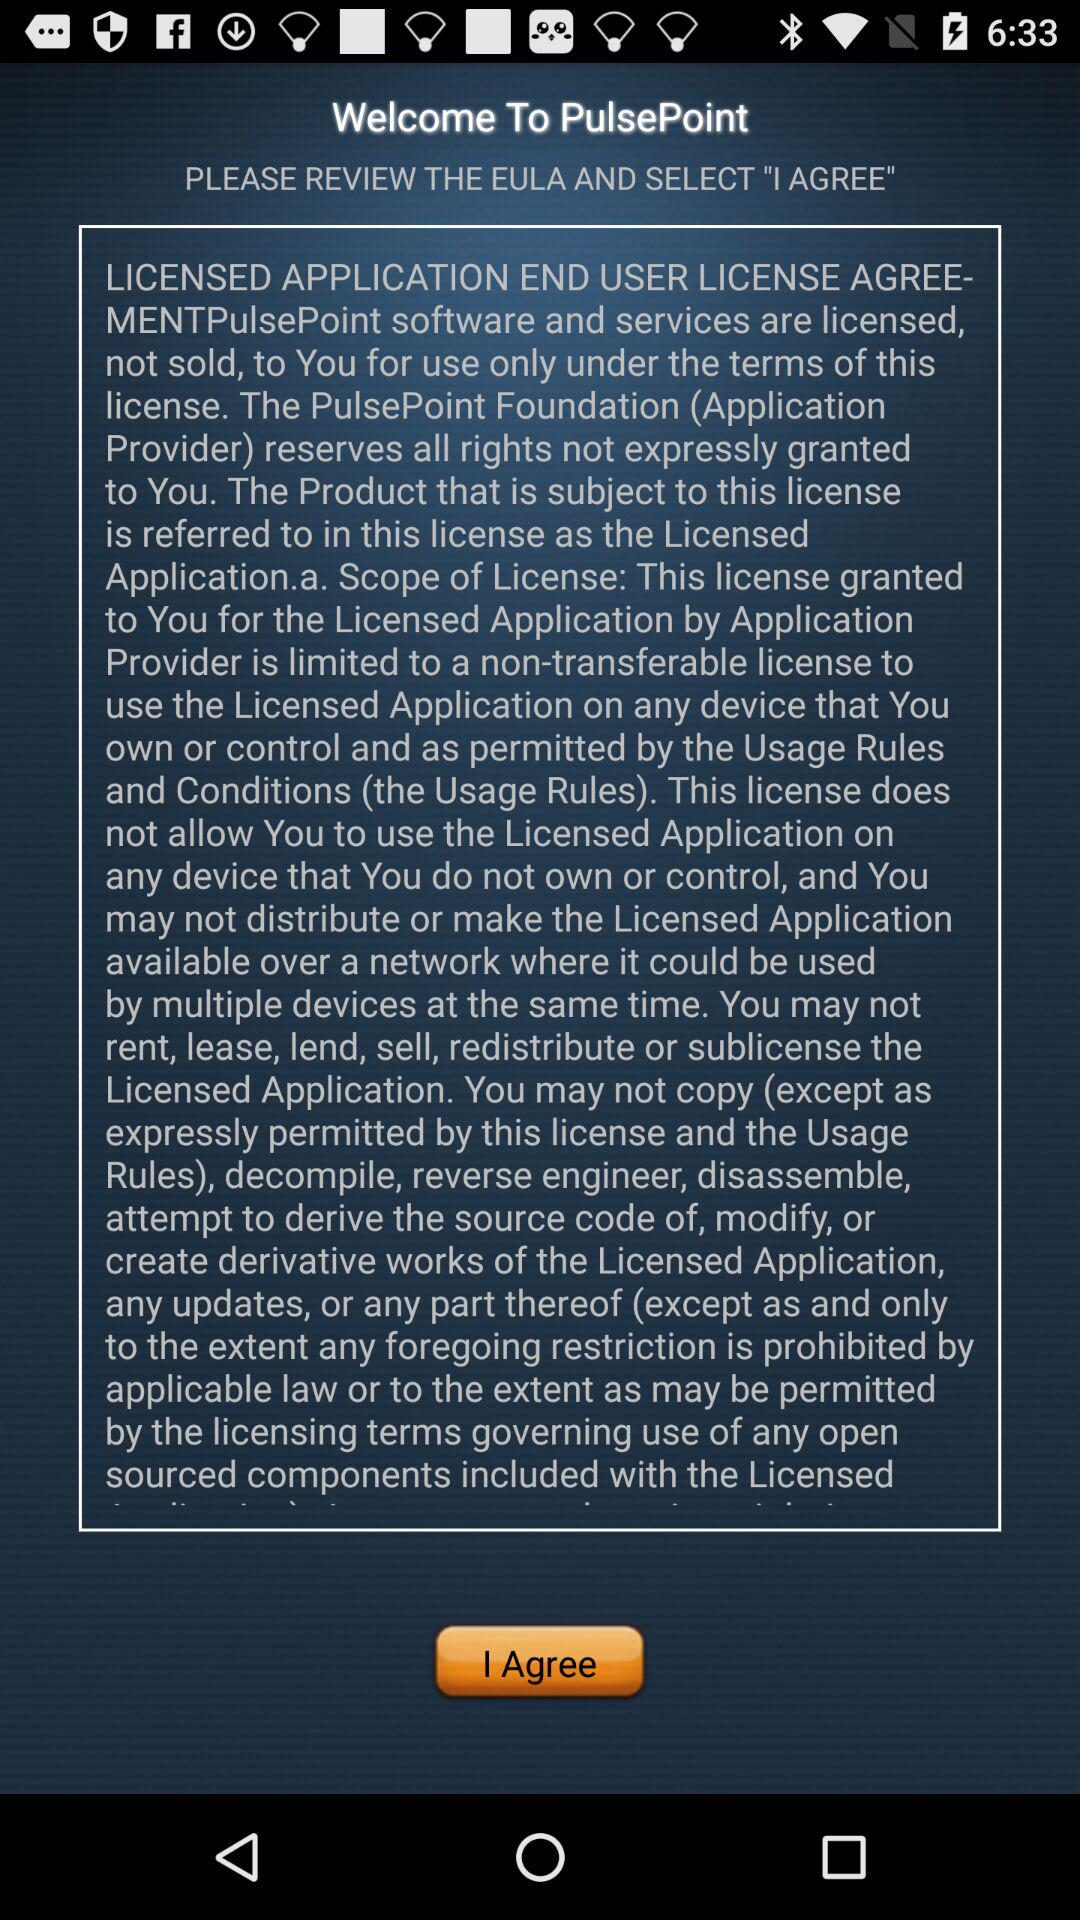What is the name of the application? The name of the application is "PulsePoint". 